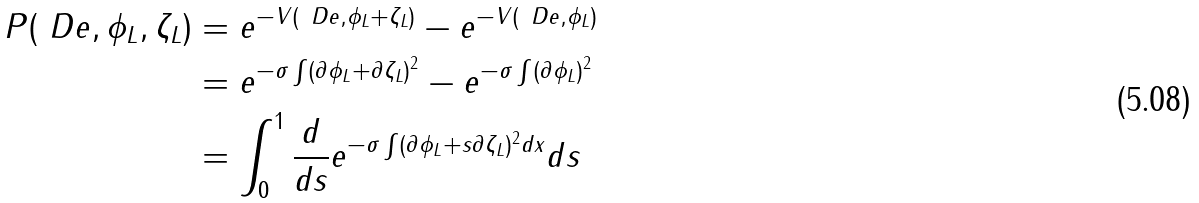<formula> <loc_0><loc_0><loc_500><loc_500>P ( \ D e , \phi _ { L } , \zeta _ { L } ) & = e ^ { - V ( \ D e , \phi _ { L } + \zeta _ { L } ) } - e ^ { - V ( \ D e , \phi _ { L } ) } \\ & = e ^ { - \sigma \int ( \partial \phi _ { L } + \partial \zeta _ { L } ) ^ { 2 } } - e ^ { - \sigma \int ( \partial \phi _ { L } ) ^ { 2 } } \\ & = \int _ { 0 } ^ { 1 } \frac { d } { d s } e ^ { - \sigma \int ( \partial \phi _ { L } + s \partial \zeta _ { L } ) ^ { 2 } d x } d s</formula> 